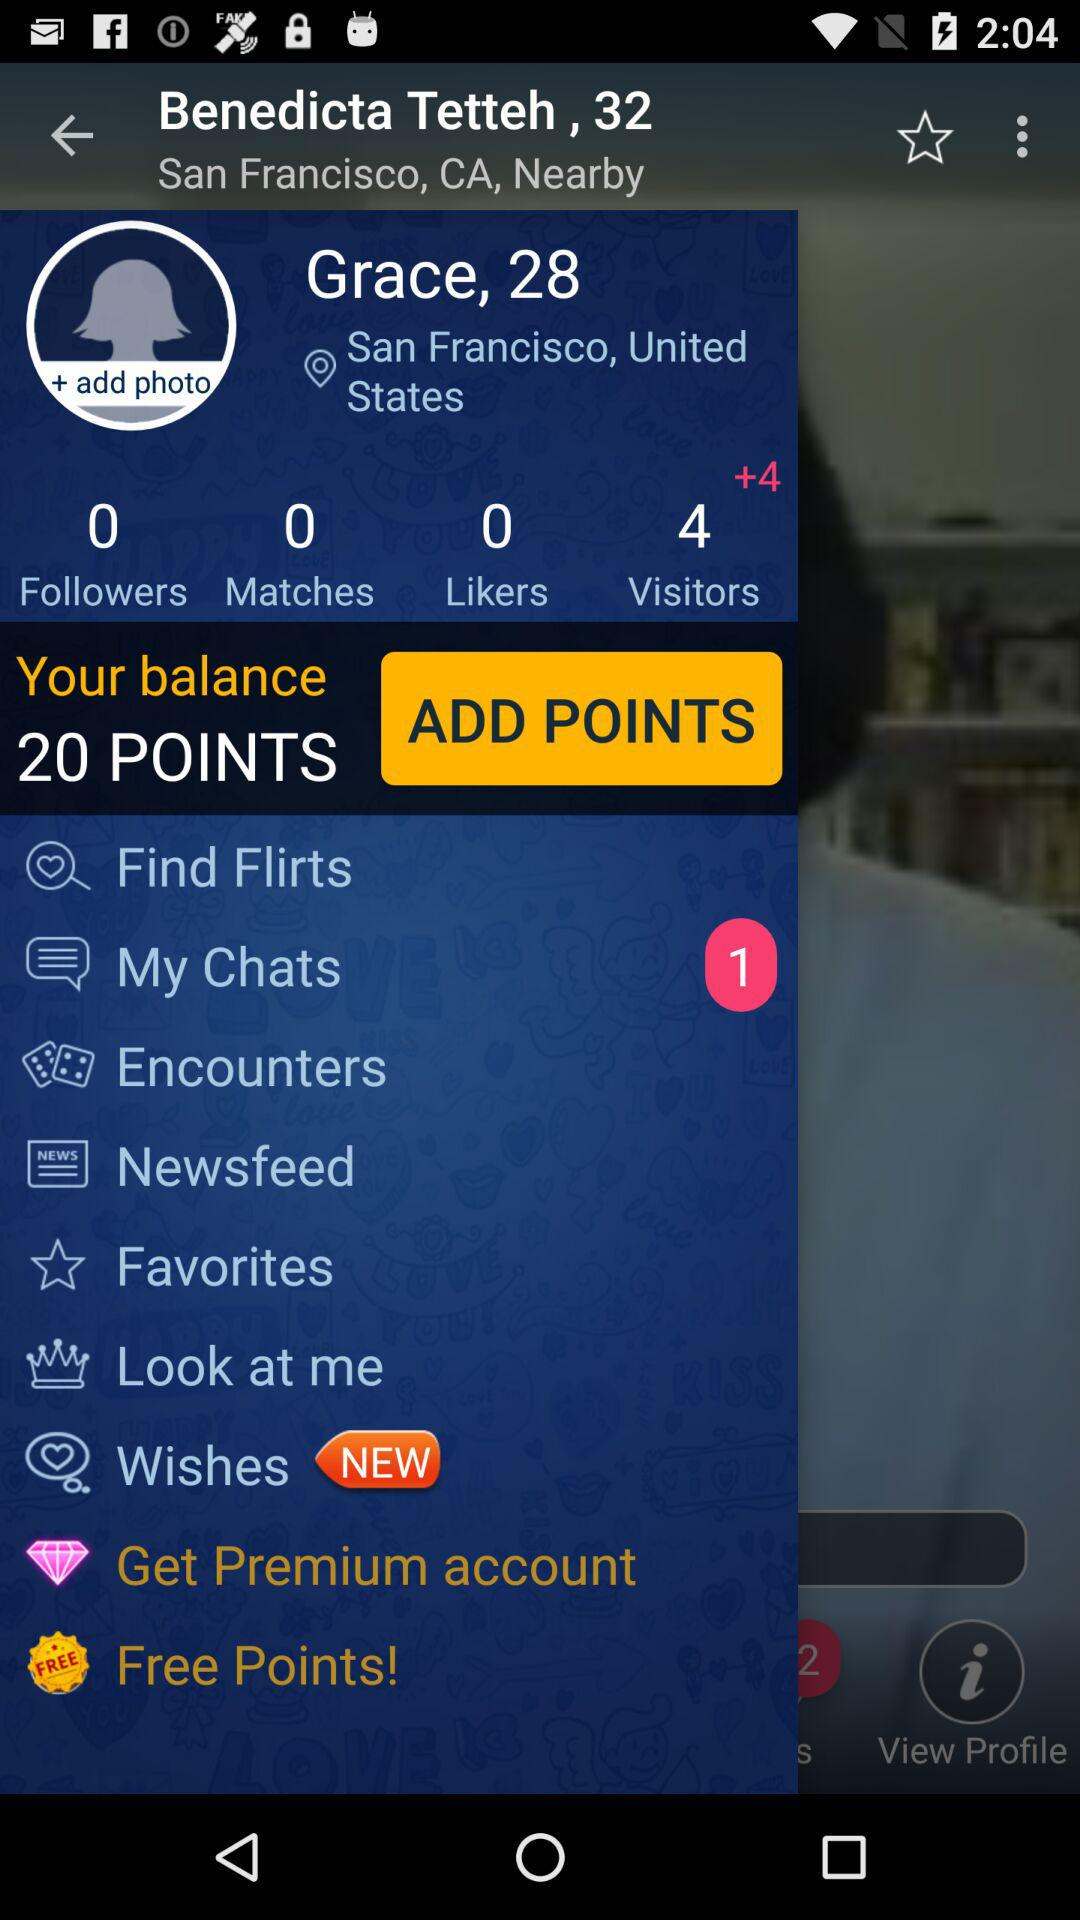What is the location of Benedicta Tetteh? The location of Benedicta Tetteh is San Francisco, CA. 